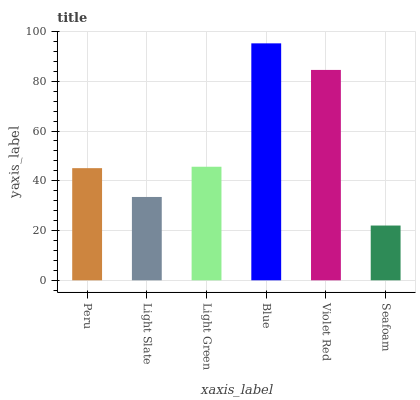Is Seafoam the minimum?
Answer yes or no. Yes. Is Blue the maximum?
Answer yes or no. Yes. Is Light Slate the minimum?
Answer yes or no. No. Is Light Slate the maximum?
Answer yes or no. No. Is Peru greater than Light Slate?
Answer yes or no. Yes. Is Light Slate less than Peru?
Answer yes or no. Yes. Is Light Slate greater than Peru?
Answer yes or no. No. Is Peru less than Light Slate?
Answer yes or no. No. Is Light Green the high median?
Answer yes or no. Yes. Is Peru the low median?
Answer yes or no. Yes. Is Seafoam the high median?
Answer yes or no. No. Is Light Green the low median?
Answer yes or no. No. 